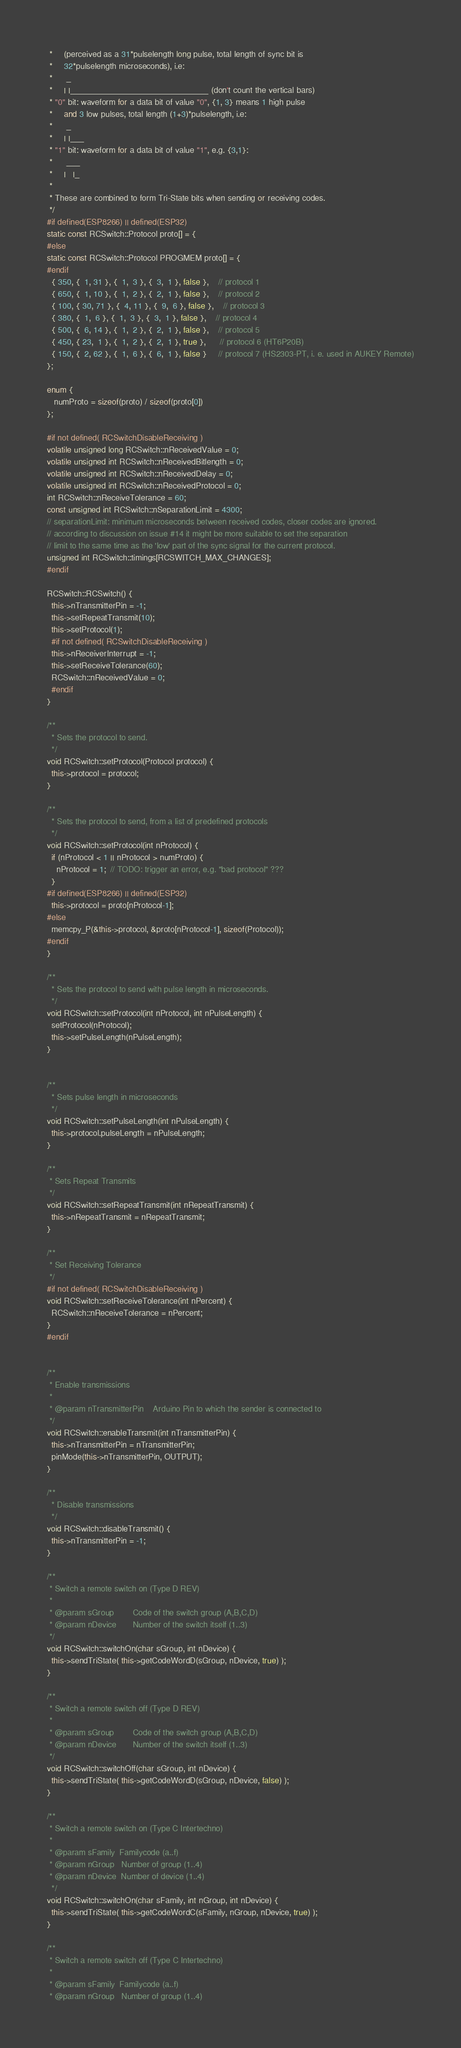Convert code to text. <code><loc_0><loc_0><loc_500><loc_500><_C++_> *     (perceived as a 31*pulselength long pulse, total length of sync bit is
 *     32*pulselength microseconds), i.e:
 *      _
 *     | |_______________________________ (don't count the vertical bars)
 * "0" bit: waveform for a data bit of value "0", {1, 3} means 1 high pulse
 *     and 3 low pulses, total length (1+3)*pulselength, i.e:
 *      _
 *     | |___
 * "1" bit: waveform for a data bit of value "1", e.g. {3,1}:
 *      ___
 *     |   |_
 *
 * These are combined to form Tri-State bits when sending or receiving codes.
 */
#if defined(ESP8266) || defined(ESP32)
static const RCSwitch::Protocol proto[] = {
#else
static const RCSwitch::Protocol PROGMEM proto[] = {
#endif
  { 350, {  1, 31 }, {  1,  3 }, {  3,  1 }, false },    // protocol 1
  { 650, {  1, 10 }, {  1,  2 }, {  2,  1 }, false },    // protocol 2
  { 100, { 30, 71 }, {  4, 11 }, {  9,  6 }, false },    // protocol 3
  { 380, {  1,  6 }, {  1,  3 }, {  3,  1 }, false },    // protocol 4
  { 500, {  6, 14 }, {  1,  2 }, {  2,  1 }, false },    // protocol 5
  { 450, { 23,  1 }, {  1,  2 }, {  2,  1 }, true },      // protocol 6 (HT6P20B)
  { 150, {  2, 62 }, {  1,  6 }, {  6,  1 }, false }     // protocol 7 (HS2303-PT, i. e. used in AUKEY Remote)
};

enum {
   numProto = sizeof(proto) / sizeof(proto[0])
};

#if not defined( RCSwitchDisableReceiving )
volatile unsigned long RCSwitch::nReceivedValue = 0;
volatile unsigned int RCSwitch::nReceivedBitlength = 0;
volatile unsigned int RCSwitch::nReceivedDelay = 0;
volatile unsigned int RCSwitch::nReceivedProtocol = 0;
int RCSwitch::nReceiveTolerance = 60;
const unsigned int RCSwitch::nSeparationLimit = 4300;
// separationLimit: minimum microseconds between received codes, closer codes are ignored.
// according to discussion on issue #14 it might be more suitable to set the separation
// limit to the same time as the 'low' part of the sync signal for the current protocol.
unsigned int RCSwitch::timings[RCSWITCH_MAX_CHANGES];
#endif

RCSwitch::RCSwitch() {
  this->nTransmitterPin = -1;
  this->setRepeatTransmit(10);
  this->setProtocol(1);
  #if not defined( RCSwitchDisableReceiving )
  this->nReceiverInterrupt = -1;
  this->setReceiveTolerance(60);
  RCSwitch::nReceivedValue = 0;
  #endif
}

/**
  * Sets the protocol to send.
  */
void RCSwitch::setProtocol(Protocol protocol) {
  this->protocol = protocol;
}

/**
  * Sets the protocol to send, from a list of predefined protocols
  */
void RCSwitch::setProtocol(int nProtocol) {
  if (nProtocol < 1 || nProtocol > numProto) {
    nProtocol = 1;  // TODO: trigger an error, e.g. "bad protocol" ???
  }
#if defined(ESP8266) || defined(ESP32)
  this->protocol = proto[nProtocol-1];
#else
  memcpy_P(&this->protocol, &proto[nProtocol-1], sizeof(Protocol));
#endif
}

/**
  * Sets the protocol to send with pulse length in microseconds.
  */
void RCSwitch::setProtocol(int nProtocol, int nPulseLength) {
  setProtocol(nProtocol);
  this->setPulseLength(nPulseLength);
}


/**
  * Sets pulse length in microseconds
  */
void RCSwitch::setPulseLength(int nPulseLength) {
  this->protocol.pulseLength = nPulseLength;
}

/**
 * Sets Repeat Transmits
 */
void RCSwitch::setRepeatTransmit(int nRepeatTransmit) {
  this->nRepeatTransmit = nRepeatTransmit;
}

/**
 * Set Receiving Tolerance
 */
#if not defined( RCSwitchDisableReceiving )
void RCSwitch::setReceiveTolerance(int nPercent) {
  RCSwitch::nReceiveTolerance = nPercent;
}
#endif
  

/**
 * Enable transmissions
 *
 * @param nTransmitterPin    Arduino Pin to which the sender is connected to
 */
void RCSwitch::enableTransmit(int nTransmitterPin) {
  this->nTransmitterPin = nTransmitterPin;
  pinMode(this->nTransmitterPin, OUTPUT);
}

/**
  * Disable transmissions
  */
void RCSwitch::disableTransmit() {
  this->nTransmitterPin = -1;
}

/**
 * Switch a remote switch on (Type D REV)
 *
 * @param sGroup        Code of the switch group (A,B,C,D)
 * @param nDevice       Number of the switch itself (1..3)
 */
void RCSwitch::switchOn(char sGroup, int nDevice) {
  this->sendTriState( this->getCodeWordD(sGroup, nDevice, true) );
}

/**
 * Switch a remote switch off (Type D REV)
 *
 * @param sGroup        Code of the switch group (A,B,C,D)
 * @param nDevice       Number of the switch itself (1..3)
 */
void RCSwitch::switchOff(char sGroup, int nDevice) {
  this->sendTriState( this->getCodeWordD(sGroup, nDevice, false) );
}

/**
 * Switch a remote switch on (Type C Intertechno)
 *
 * @param sFamily  Familycode (a..f)
 * @param nGroup   Number of group (1..4)
 * @param nDevice  Number of device (1..4)
  */
void RCSwitch::switchOn(char sFamily, int nGroup, int nDevice) {
  this->sendTriState( this->getCodeWordC(sFamily, nGroup, nDevice, true) );
}

/**
 * Switch a remote switch off (Type C Intertechno)
 *
 * @param sFamily  Familycode (a..f)
 * @param nGroup   Number of group (1..4)</code> 